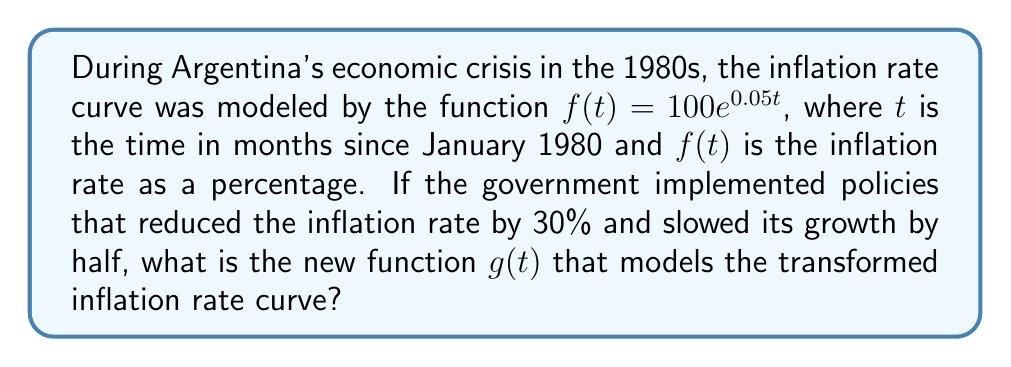Can you answer this question? To transform the original function $f(t) = 100e^{0.05t}$ into the new function $g(t)$, we need to apply two transformations:

1. Reduce the inflation rate by 30%:
   This is a vertical scaling transformation. We multiply the function by 0.7 (1 - 0.3 = 0.7).
   $f_1(t) = 0.7 \cdot 100e^{0.05t} = 70e^{0.05t}$

2. Slow the growth by half:
   This affects the exponent. We multiply the exponent by 0.5.
   $g(t) = 70e^{0.5 \cdot 0.05t} = 70e^{0.025t}$

Therefore, the new function $g(t)$ that models the transformed inflation rate curve is:

$$g(t) = 70e^{0.025t}$$

This function represents the reduced inflation rate with slower growth over time.
Answer: $g(t) = 70e^{0.025t}$ 